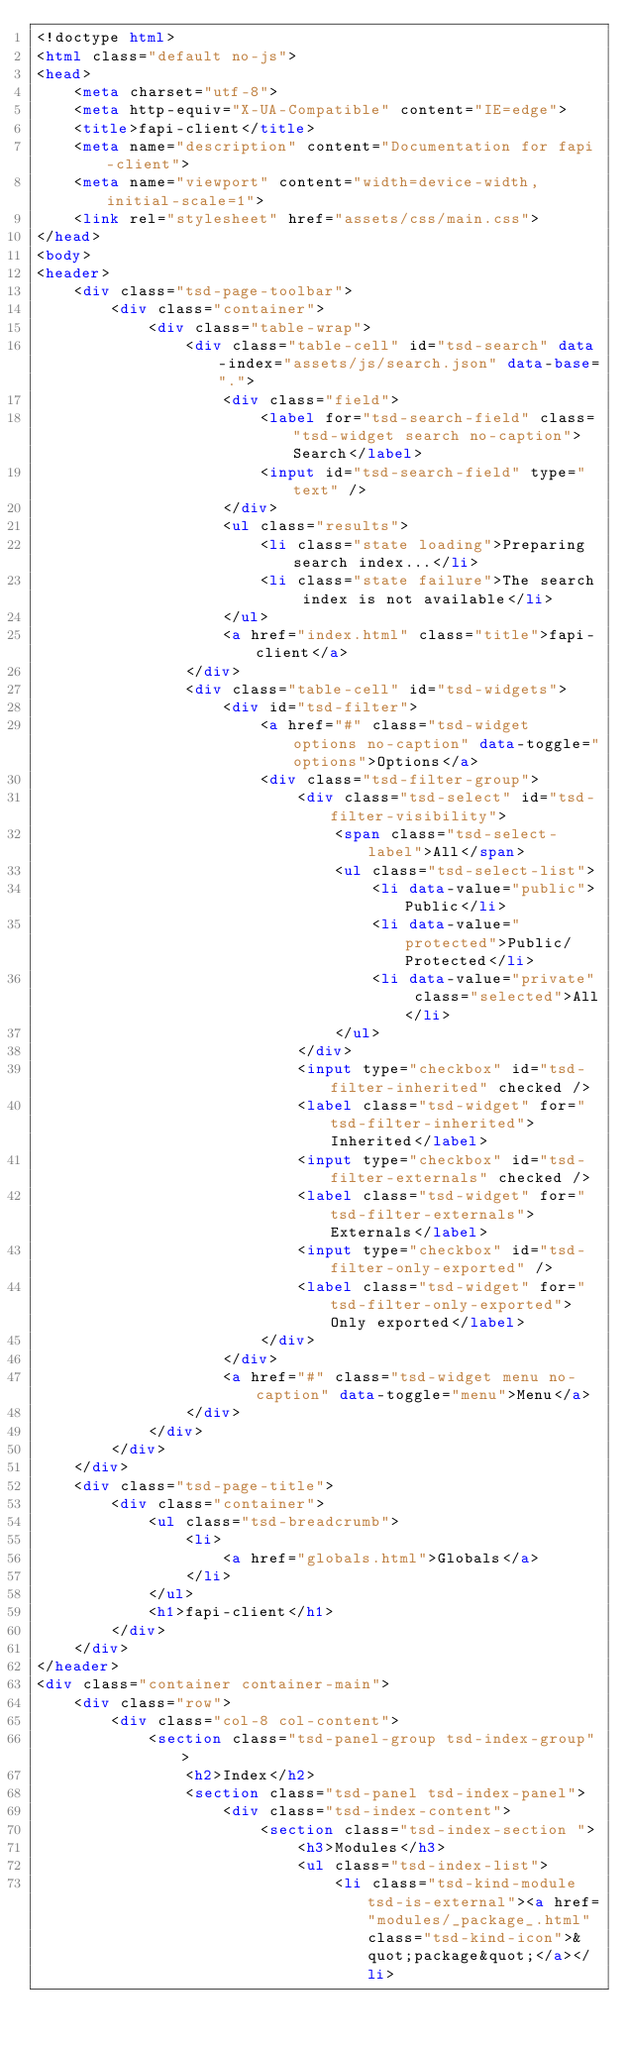Convert code to text. <code><loc_0><loc_0><loc_500><loc_500><_HTML_><!doctype html>
<html class="default no-js">
<head>
	<meta charset="utf-8">
	<meta http-equiv="X-UA-Compatible" content="IE=edge">
	<title>fapi-client</title>
	<meta name="description" content="Documentation for fapi-client">
	<meta name="viewport" content="width=device-width, initial-scale=1">
	<link rel="stylesheet" href="assets/css/main.css">
</head>
<body>
<header>
	<div class="tsd-page-toolbar">
		<div class="container">
			<div class="table-wrap">
				<div class="table-cell" id="tsd-search" data-index="assets/js/search.json" data-base=".">
					<div class="field">
						<label for="tsd-search-field" class="tsd-widget search no-caption">Search</label>
						<input id="tsd-search-field" type="text" />
					</div>
					<ul class="results">
						<li class="state loading">Preparing search index...</li>
						<li class="state failure">The search index is not available</li>
					</ul>
					<a href="index.html" class="title">fapi-client</a>
				</div>
				<div class="table-cell" id="tsd-widgets">
					<div id="tsd-filter">
						<a href="#" class="tsd-widget options no-caption" data-toggle="options">Options</a>
						<div class="tsd-filter-group">
							<div class="tsd-select" id="tsd-filter-visibility">
								<span class="tsd-select-label">All</span>
								<ul class="tsd-select-list">
									<li data-value="public">Public</li>
									<li data-value="protected">Public/Protected</li>
									<li data-value="private" class="selected">All</li>
								</ul>
							</div>
							<input type="checkbox" id="tsd-filter-inherited" checked />
							<label class="tsd-widget" for="tsd-filter-inherited">Inherited</label>
							<input type="checkbox" id="tsd-filter-externals" checked />
							<label class="tsd-widget" for="tsd-filter-externals">Externals</label>
							<input type="checkbox" id="tsd-filter-only-exported" />
							<label class="tsd-widget" for="tsd-filter-only-exported">Only exported</label>
						</div>
					</div>
					<a href="#" class="tsd-widget menu no-caption" data-toggle="menu">Menu</a>
				</div>
			</div>
		</div>
	</div>
	<div class="tsd-page-title">
		<div class="container">
			<ul class="tsd-breadcrumb">
				<li>
					<a href="globals.html">Globals</a>
				</li>
			</ul>
			<h1>fapi-client</h1>
		</div>
	</div>
</header>
<div class="container container-main">
	<div class="row">
		<div class="col-8 col-content">
			<section class="tsd-panel-group tsd-index-group">
				<h2>Index</h2>
				<section class="tsd-panel tsd-index-panel">
					<div class="tsd-index-content">
						<section class="tsd-index-section ">
							<h3>Modules</h3>
							<ul class="tsd-index-list">
								<li class="tsd-kind-module tsd-is-external"><a href="modules/_package_.html" class="tsd-kind-icon">&quot;package&quot;</a></li></code> 